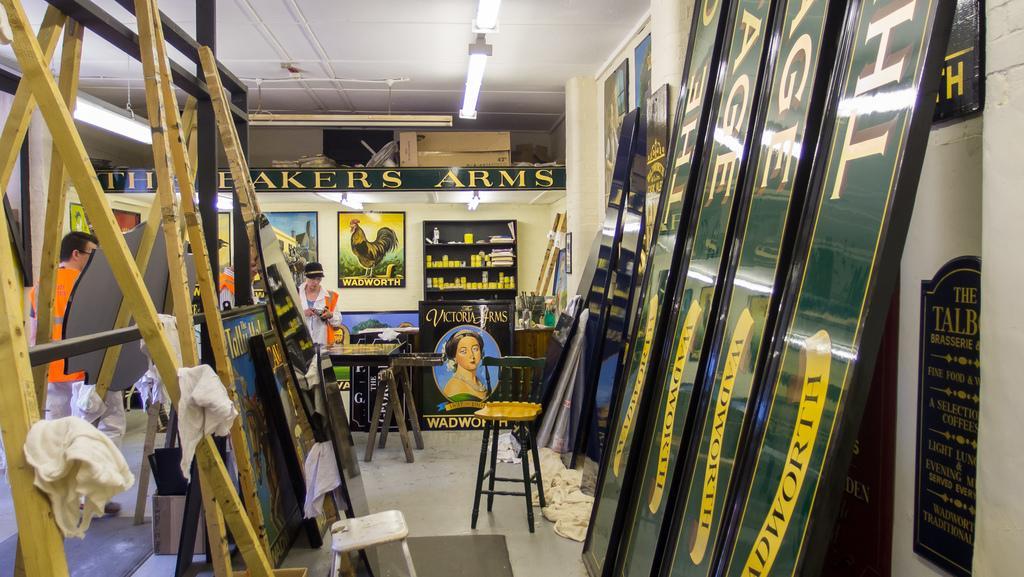How would you summarize this image in a sentence or two? In this image we can see three persons standing on the floor. One person is wearing black. In the center of the image we can see a chair placed on the floor. To the left side of the image we can see group of clothes placed on wooden sticks. To the right side we can see photo frames. In the background ,we can see a sign board with text on it a cupboard with several items ,lights and a cardboard box. 